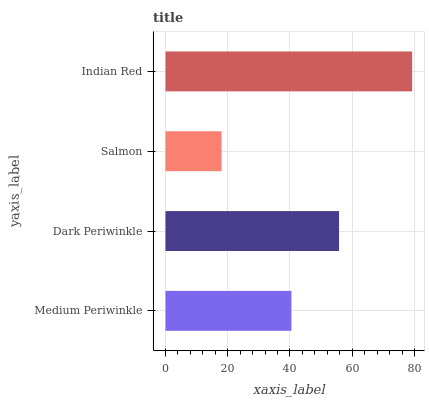Is Salmon the minimum?
Answer yes or no. Yes. Is Indian Red the maximum?
Answer yes or no. Yes. Is Dark Periwinkle the minimum?
Answer yes or no. No. Is Dark Periwinkle the maximum?
Answer yes or no. No. Is Dark Periwinkle greater than Medium Periwinkle?
Answer yes or no. Yes. Is Medium Periwinkle less than Dark Periwinkle?
Answer yes or no. Yes. Is Medium Periwinkle greater than Dark Periwinkle?
Answer yes or no. No. Is Dark Periwinkle less than Medium Periwinkle?
Answer yes or no. No. Is Dark Periwinkle the high median?
Answer yes or no. Yes. Is Medium Periwinkle the low median?
Answer yes or no. Yes. Is Indian Red the high median?
Answer yes or no. No. Is Salmon the low median?
Answer yes or no. No. 